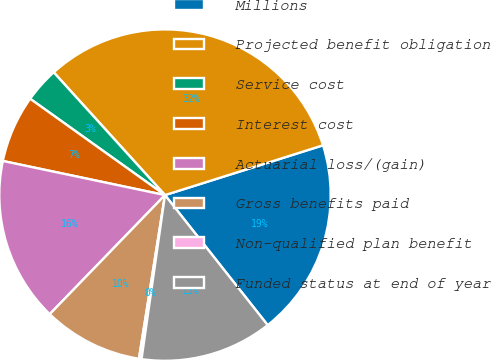Convert chart. <chart><loc_0><loc_0><loc_500><loc_500><pie_chart><fcel>Millions<fcel>Projected benefit obligation<fcel>Service cost<fcel>Interest cost<fcel>Actuarial loss/(gain)<fcel>Gross benefits paid<fcel>Non-qualified plan benefit<fcel>Funded status at end of year<nl><fcel>19.22%<fcel>31.86%<fcel>3.41%<fcel>6.57%<fcel>16.06%<fcel>9.73%<fcel>0.25%<fcel>12.9%<nl></chart> 